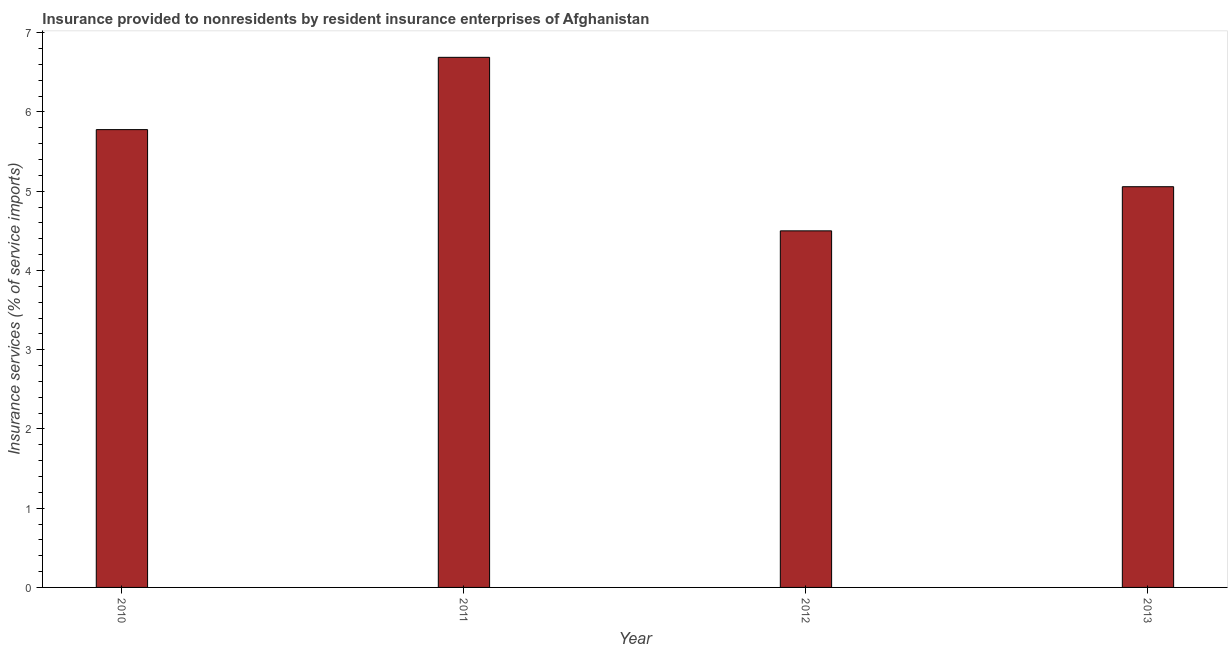Does the graph contain any zero values?
Offer a very short reply. No. What is the title of the graph?
Ensure brevity in your answer.  Insurance provided to nonresidents by resident insurance enterprises of Afghanistan. What is the label or title of the X-axis?
Provide a short and direct response. Year. What is the label or title of the Y-axis?
Offer a terse response. Insurance services (% of service imports). What is the insurance and financial services in 2011?
Ensure brevity in your answer.  6.69. Across all years, what is the maximum insurance and financial services?
Keep it short and to the point. 6.69. Across all years, what is the minimum insurance and financial services?
Offer a very short reply. 4.5. In which year was the insurance and financial services minimum?
Offer a terse response. 2012. What is the sum of the insurance and financial services?
Your response must be concise. 22.02. What is the difference between the insurance and financial services in 2010 and 2011?
Provide a short and direct response. -0.91. What is the average insurance and financial services per year?
Your answer should be very brief. 5.51. What is the median insurance and financial services?
Offer a terse response. 5.42. In how many years, is the insurance and financial services greater than 6.4 %?
Give a very brief answer. 1. What is the ratio of the insurance and financial services in 2011 to that in 2012?
Provide a succinct answer. 1.49. Is the difference between the insurance and financial services in 2010 and 2013 greater than the difference between any two years?
Make the answer very short. No. What is the difference between the highest and the second highest insurance and financial services?
Offer a very short reply. 0.91. What is the difference between the highest and the lowest insurance and financial services?
Give a very brief answer. 2.19. How many bars are there?
Give a very brief answer. 4. Are all the bars in the graph horizontal?
Keep it short and to the point. No. How many years are there in the graph?
Give a very brief answer. 4. What is the Insurance services (% of service imports) of 2010?
Ensure brevity in your answer.  5.78. What is the Insurance services (% of service imports) in 2011?
Provide a succinct answer. 6.69. What is the Insurance services (% of service imports) in 2012?
Make the answer very short. 4.5. What is the Insurance services (% of service imports) in 2013?
Offer a very short reply. 5.06. What is the difference between the Insurance services (% of service imports) in 2010 and 2011?
Offer a terse response. -0.91. What is the difference between the Insurance services (% of service imports) in 2010 and 2012?
Your answer should be very brief. 1.28. What is the difference between the Insurance services (% of service imports) in 2010 and 2013?
Your answer should be compact. 0.72. What is the difference between the Insurance services (% of service imports) in 2011 and 2012?
Offer a terse response. 2.19. What is the difference between the Insurance services (% of service imports) in 2011 and 2013?
Provide a succinct answer. 1.63. What is the difference between the Insurance services (% of service imports) in 2012 and 2013?
Ensure brevity in your answer.  -0.56. What is the ratio of the Insurance services (% of service imports) in 2010 to that in 2011?
Make the answer very short. 0.86. What is the ratio of the Insurance services (% of service imports) in 2010 to that in 2012?
Keep it short and to the point. 1.28. What is the ratio of the Insurance services (% of service imports) in 2010 to that in 2013?
Your response must be concise. 1.14. What is the ratio of the Insurance services (% of service imports) in 2011 to that in 2012?
Give a very brief answer. 1.49. What is the ratio of the Insurance services (% of service imports) in 2011 to that in 2013?
Keep it short and to the point. 1.32. What is the ratio of the Insurance services (% of service imports) in 2012 to that in 2013?
Provide a short and direct response. 0.89. 